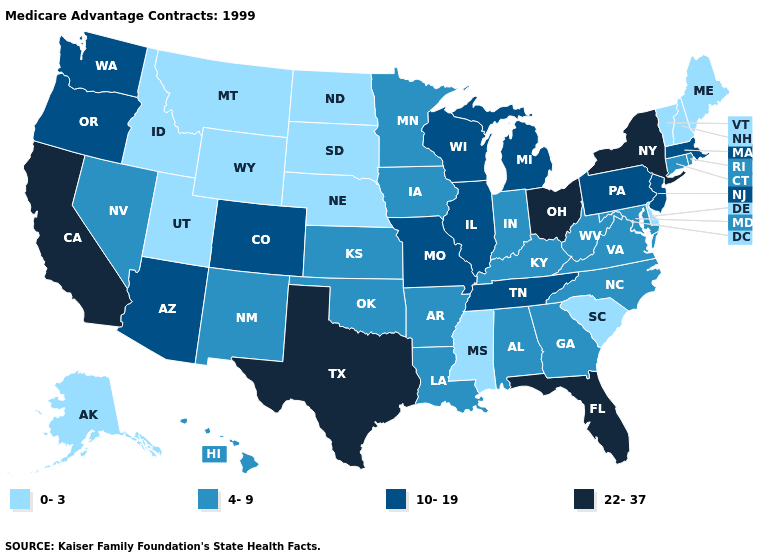What is the highest value in the South ?
Short answer required. 22-37. Name the states that have a value in the range 0-3?
Keep it brief. Alaska, Delaware, Idaho, Maine, Mississippi, Montana, North Dakota, Nebraska, New Hampshire, South Carolina, South Dakota, Utah, Vermont, Wyoming. Name the states that have a value in the range 4-9?
Answer briefly. Alabama, Arkansas, Connecticut, Georgia, Hawaii, Iowa, Indiana, Kansas, Kentucky, Louisiana, Maryland, Minnesota, North Carolina, New Mexico, Nevada, Oklahoma, Rhode Island, Virginia, West Virginia. Does North Dakota have the lowest value in the USA?
Give a very brief answer. Yes. Does North Dakota have a lower value than Oklahoma?
Concise answer only. Yes. Which states hav the highest value in the South?
Short answer required. Florida, Texas. Among the states that border Tennessee , does Mississippi have the lowest value?
Be succinct. Yes. Name the states that have a value in the range 10-19?
Keep it brief. Arizona, Colorado, Illinois, Massachusetts, Michigan, Missouri, New Jersey, Oregon, Pennsylvania, Tennessee, Washington, Wisconsin. What is the highest value in states that border Illinois?
Concise answer only. 10-19. Does the map have missing data?
Write a very short answer. No. Does Oregon have the highest value in the West?
Keep it brief. No. What is the value of Indiana?
Give a very brief answer. 4-9. What is the highest value in the USA?
Short answer required. 22-37. What is the value of Oklahoma?
Answer briefly. 4-9. What is the lowest value in the MidWest?
Give a very brief answer. 0-3. 